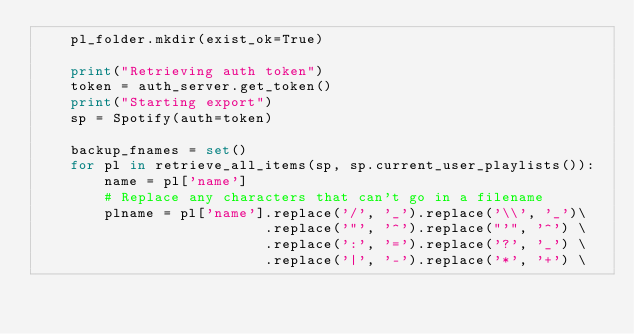Convert code to text. <code><loc_0><loc_0><loc_500><loc_500><_Python_>    pl_folder.mkdir(exist_ok=True)

    print("Retrieving auth token")
    token = auth_server.get_token()
    print("Starting export")
    sp = Spotify(auth=token)

    backup_fnames = set()
    for pl in retrieve_all_items(sp, sp.current_user_playlists()):
        name = pl['name']
        # Replace any characters that can't go in a filename
        plname = pl['name'].replace('/', '_').replace('\\', '_')\
                           .replace('"', '^').replace("'", '^') \
                           .replace(':', '=').replace('?', '_') \
                           .replace('|', '-').replace('*', '+') \</code> 